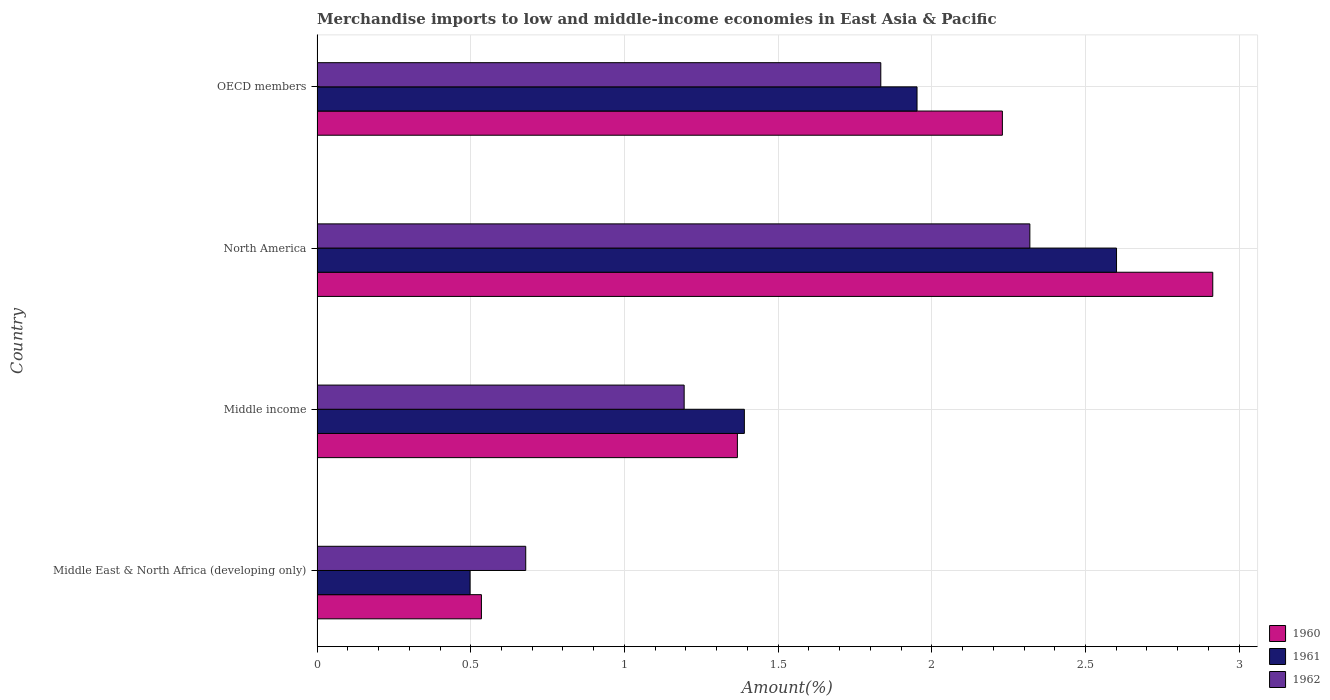How many different coloured bars are there?
Provide a short and direct response. 3. Are the number of bars on each tick of the Y-axis equal?
Offer a terse response. Yes. How many bars are there on the 3rd tick from the top?
Your answer should be very brief. 3. What is the percentage of amount earned from merchandise imports in 1961 in Middle income?
Offer a very short reply. 1.39. Across all countries, what is the maximum percentage of amount earned from merchandise imports in 1962?
Your answer should be compact. 2.32. Across all countries, what is the minimum percentage of amount earned from merchandise imports in 1960?
Your answer should be compact. 0.53. In which country was the percentage of amount earned from merchandise imports in 1961 maximum?
Ensure brevity in your answer.  North America. In which country was the percentage of amount earned from merchandise imports in 1960 minimum?
Your response must be concise. Middle East & North Africa (developing only). What is the total percentage of amount earned from merchandise imports in 1960 in the graph?
Provide a short and direct response. 7.05. What is the difference between the percentage of amount earned from merchandise imports in 1962 in Middle East & North Africa (developing only) and that in Middle income?
Offer a terse response. -0.52. What is the difference between the percentage of amount earned from merchandise imports in 1962 in Middle East & North Africa (developing only) and the percentage of amount earned from merchandise imports in 1961 in OECD members?
Offer a terse response. -1.27. What is the average percentage of amount earned from merchandise imports in 1961 per country?
Offer a terse response. 1.61. What is the difference between the percentage of amount earned from merchandise imports in 1960 and percentage of amount earned from merchandise imports in 1962 in Middle East & North Africa (developing only)?
Make the answer very short. -0.14. In how many countries, is the percentage of amount earned from merchandise imports in 1960 greater than 0.4 %?
Ensure brevity in your answer.  4. What is the ratio of the percentage of amount earned from merchandise imports in 1961 in North America to that in OECD members?
Your answer should be compact. 1.33. What is the difference between the highest and the second highest percentage of amount earned from merchandise imports in 1960?
Your answer should be compact. 0.68. What is the difference between the highest and the lowest percentage of amount earned from merchandise imports in 1961?
Keep it short and to the point. 2.1. In how many countries, is the percentage of amount earned from merchandise imports in 1960 greater than the average percentage of amount earned from merchandise imports in 1960 taken over all countries?
Your answer should be compact. 2. Is the sum of the percentage of amount earned from merchandise imports in 1960 in Middle East & North Africa (developing only) and OECD members greater than the maximum percentage of amount earned from merchandise imports in 1962 across all countries?
Provide a short and direct response. Yes. How many bars are there?
Provide a succinct answer. 12. How many countries are there in the graph?
Provide a succinct answer. 4. Are the values on the major ticks of X-axis written in scientific E-notation?
Your answer should be compact. No. Does the graph contain any zero values?
Your answer should be very brief. No. Where does the legend appear in the graph?
Ensure brevity in your answer.  Bottom right. How many legend labels are there?
Provide a succinct answer. 3. What is the title of the graph?
Your answer should be compact. Merchandise imports to low and middle-income economies in East Asia & Pacific. What is the label or title of the X-axis?
Provide a short and direct response. Amount(%). What is the Amount(%) of 1960 in Middle East & North Africa (developing only)?
Your response must be concise. 0.53. What is the Amount(%) in 1961 in Middle East & North Africa (developing only)?
Give a very brief answer. 0.5. What is the Amount(%) in 1962 in Middle East & North Africa (developing only)?
Provide a short and direct response. 0.68. What is the Amount(%) of 1960 in Middle income?
Ensure brevity in your answer.  1.37. What is the Amount(%) in 1961 in Middle income?
Give a very brief answer. 1.39. What is the Amount(%) of 1962 in Middle income?
Ensure brevity in your answer.  1.19. What is the Amount(%) of 1960 in North America?
Offer a terse response. 2.91. What is the Amount(%) of 1961 in North America?
Your response must be concise. 2.6. What is the Amount(%) in 1962 in North America?
Give a very brief answer. 2.32. What is the Amount(%) of 1960 in OECD members?
Offer a very short reply. 2.23. What is the Amount(%) in 1961 in OECD members?
Ensure brevity in your answer.  1.95. What is the Amount(%) of 1962 in OECD members?
Make the answer very short. 1.83. Across all countries, what is the maximum Amount(%) in 1960?
Provide a succinct answer. 2.91. Across all countries, what is the maximum Amount(%) in 1961?
Offer a terse response. 2.6. Across all countries, what is the maximum Amount(%) of 1962?
Make the answer very short. 2.32. Across all countries, what is the minimum Amount(%) in 1960?
Provide a succinct answer. 0.53. Across all countries, what is the minimum Amount(%) of 1961?
Provide a succinct answer. 0.5. Across all countries, what is the minimum Amount(%) of 1962?
Your answer should be very brief. 0.68. What is the total Amount(%) in 1960 in the graph?
Your answer should be very brief. 7.05. What is the total Amount(%) in 1961 in the graph?
Offer a terse response. 6.44. What is the total Amount(%) of 1962 in the graph?
Provide a short and direct response. 6.03. What is the difference between the Amount(%) in 1960 in Middle East & North Africa (developing only) and that in Middle income?
Offer a terse response. -0.83. What is the difference between the Amount(%) of 1961 in Middle East & North Africa (developing only) and that in Middle income?
Give a very brief answer. -0.89. What is the difference between the Amount(%) of 1962 in Middle East & North Africa (developing only) and that in Middle income?
Your answer should be compact. -0.52. What is the difference between the Amount(%) of 1960 in Middle East & North Africa (developing only) and that in North America?
Provide a succinct answer. -2.38. What is the difference between the Amount(%) in 1961 in Middle East & North Africa (developing only) and that in North America?
Provide a short and direct response. -2.1. What is the difference between the Amount(%) of 1962 in Middle East & North Africa (developing only) and that in North America?
Make the answer very short. -1.64. What is the difference between the Amount(%) of 1960 in Middle East & North Africa (developing only) and that in OECD members?
Provide a succinct answer. -1.69. What is the difference between the Amount(%) of 1961 in Middle East & North Africa (developing only) and that in OECD members?
Provide a short and direct response. -1.45. What is the difference between the Amount(%) in 1962 in Middle East & North Africa (developing only) and that in OECD members?
Provide a succinct answer. -1.16. What is the difference between the Amount(%) in 1960 in Middle income and that in North America?
Offer a terse response. -1.55. What is the difference between the Amount(%) in 1961 in Middle income and that in North America?
Keep it short and to the point. -1.21. What is the difference between the Amount(%) in 1962 in Middle income and that in North America?
Provide a succinct answer. -1.12. What is the difference between the Amount(%) in 1960 in Middle income and that in OECD members?
Your answer should be very brief. -0.86. What is the difference between the Amount(%) of 1961 in Middle income and that in OECD members?
Your response must be concise. -0.56. What is the difference between the Amount(%) of 1962 in Middle income and that in OECD members?
Keep it short and to the point. -0.64. What is the difference between the Amount(%) of 1960 in North America and that in OECD members?
Offer a very short reply. 0.68. What is the difference between the Amount(%) of 1961 in North America and that in OECD members?
Your response must be concise. 0.65. What is the difference between the Amount(%) in 1962 in North America and that in OECD members?
Provide a short and direct response. 0.48. What is the difference between the Amount(%) of 1960 in Middle East & North Africa (developing only) and the Amount(%) of 1961 in Middle income?
Offer a terse response. -0.86. What is the difference between the Amount(%) in 1960 in Middle East & North Africa (developing only) and the Amount(%) in 1962 in Middle income?
Give a very brief answer. -0.66. What is the difference between the Amount(%) of 1961 in Middle East & North Africa (developing only) and the Amount(%) of 1962 in Middle income?
Keep it short and to the point. -0.7. What is the difference between the Amount(%) in 1960 in Middle East & North Africa (developing only) and the Amount(%) in 1961 in North America?
Offer a terse response. -2.07. What is the difference between the Amount(%) of 1960 in Middle East & North Africa (developing only) and the Amount(%) of 1962 in North America?
Provide a short and direct response. -1.78. What is the difference between the Amount(%) in 1961 in Middle East & North Africa (developing only) and the Amount(%) in 1962 in North America?
Offer a terse response. -1.82. What is the difference between the Amount(%) in 1960 in Middle East & North Africa (developing only) and the Amount(%) in 1961 in OECD members?
Provide a succinct answer. -1.42. What is the difference between the Amount(%) of 1960 in Middle East & North Africa (developing only) and the Amount(%) of 1962 in OECD members?
Offer a very short reply. -1.3. What is the difference between the Amount(%) of 1961 in Middle East & North Africa (developing only) and the Amount(%) of 1962 in OECD members?
Make the answer very short. -1.34. What is the difference between the Amount(%) in 1960 in Middle income and the Amount(%) in 1961 in North America?
Keep it short and to the point. -1.23. What is the difference between the Amount(%) of 1960 in Middle income and the Amount(%) of 1962 in North America?
Ensure brevity in your answer.  -0.95. What is the difference between the Amount(%) of 1961 in Middle income and the Amount(%) of 1962 in North America?
Ensure brevity in your answer.  -0.93. What is the difference between the Amount(%) of 1960 in Middle income and the Amount(%) of 1961 in OECD members?
Your answer should be very brief. -0.58. What is the difference between the Amount(%) in 1960 in Middle income and the Amount(%) in 1962 in OECD members?
Your answer should be compact. -0.47. What is the difference between the Amount(%) of 1961 in Middle income and the Amount(%) of 1962 in OECD members?
Give a very brief answer. -0.44. What is the difference between the Amount(%) in 1960 in North America and the Amount(%) in 1961 in OECD members?
Ensure brevity in your answer.  0.96. What is the difference between the Amount(%) in 1961 in North America and the Amount(%) in 1962 in OECD members?
Ensure brevity in your answer.  0.77. What is the average Amount(%) of 1960 per country?
Offer a very short reply. 1.76. What is the average Amount(%) of 1961 per country?
Keep it short and to the point. 1.61. What is the average Amount(%) in 1962 per country?
Your response must be concise. 1.51. What is the difference between the Amount(%) in 1960 and Amount(%) in 1961 in Middle East & North Africa (developing only)?
Your answer should be very brief. 0.04. What is the difference between the Amount(%) in 1960 and Amount(%) in 1962 in Middle East & North Africa (developing only)?
Offer a terse response. -0.14. What is the difference between the Amount(%) of 1961 and Amount(%) of 1962 in Middle East & North Africa (developing only)?
Give a very brief answer. -0.18. What is the difference between the Amount(%) of 1960 and Amount(%) of 1961 in Middle income?
Your answer should be very brief. -0.02. What is the difference between the Amount(%) in 1960 and Amount(%) in 1962 in Middle income?
Your answer should be very brief. 0.17. What is the difference between the Amount(%) of 1961 and Amount(%) of 1962 in Middle income?
Provide a succinct answer. 0.2. What is the difference between the Amount(%) of 1960 and Amount(%) of 1961 in North America?
Provide a short and direct response. 0.31. What is the difference between the Amount(%) in 1960 and Amount(%) in 1962 in North America?
Offer a terse response. 0.6. What is the difference between the Amount(%) in 1961 and Amount(%) in 1962 in North America?
Keep it short and to the point. 0.28. What is the difference between the Amount(%) of 1960 and Amount(%) of 1961 in OECD members?
Make the answer very short. 0.28. What is the difference between the Amount(%) in 1960 and Amount(%) in 1962 in OECD members?
Your answer should be very brief. 0.4. What is the difference between the Amount(%) in 1961 and Amount(%) in 1962 in OECD members?
Your answer should be very brief. 0.12. What is the ratio of the Amount(%) of 1960 in Middle East & North Africa (developing only) to that in Middle income?
Make the answer very short. 0.39. What is the ratio of the Amount(%) in 1961 in Middle East & North Africa (developing only) to that in Middle income?
Your response must be concise. 0.36. What is the ratio of the Amount(%) of 1962 in Middle East & North Africa (developing only) to that in Middle income?
Make the answer very short. 0.57. What is the ratio of the Amount(%) in 1960 in Middle East & North Africa (developing only) to that in North America?
Offer a terse response. 0.18. What is the ratio of the Amount(%) of 1961 in Middle East & North Africa (developing only) to that in North America?
Keep it short and to the point. 0.19. What is the ratio of the Amount(%) in 1962 in Middle East & North Africa (developing only) to that in North America?
Provide a succinct answer. 0.29. What is the ratio of the Amount(%) of 1960 in Middle East & North Africa (developing only) to that in OECD members?
Provide a succinct answer. 0.24. What is the ratio of the Amount(%) of 1961 in Middle East & North Africa (developing only) to that in OECD members?
Offer a very short reply. 0.26. What is the ratio of the Amount(%) of 1962 in Middle East & North Africa (developing only) to that in OECD members?
Ensure brevity in your answer.  0.37. What is the ratio of the Amount(%) in 1960 in Middle income to that in North America?
Your answer should be compact. 0.47. What is the ratio of the Amount(%) in 1961 in Middle income to that in North America?
Provide a succinct answer. 0.53. What is the ratio of the Amount(%) of 1962 in Middle income to that in North America?
Your answer should be compact. 0.52. What is the ratio of the Amount(%) of 1960 in Middle income to that in OECD members?
Give a very brief answer. 0.61. What is the ratio of the Amount(%) of 1961 in Middle income to that in OECD members?
Keep it short and to the point. 0.71. What is the ratio of the Amount(%) of 1962 in Middle income to that in OECD members?
Provide a succinct answer. 0.65. What is the ratio of the Amount(%) in 1960 in North America to that in OECD members?
Provide a short and direct response. 1.31. What is the ratio of the Amount(%) of 1961 in North America to that in OECD members?
Keep it short and to the point. 1.33. What is the ratio of the Amount(%) in 1962 in North America to that in OECD members?
Make the answer very short. 1.26. What is the difference between the highest and the second highest Amount(%) in 1960?
Your answer should be very brief. 0.68. What is the difference between the highest and the second highest Amount(%) in 1961?
Provide a short and direct response. 0.65. What is the difference between the highest and the second highest Amount(%) in 1962?
Keep it short and to the point. 0.48. What is the difference between the highest and the lowest Amount(%) of 1960?
Your answer should be very brief. 2.38. What is the difference between the highest and the lowest Amount(%) of 1961?
Make the answer very short. 2.1. What is the difference between the highest and the lowest Amount(%) of 1962?
Give a very brief answer. 1.64. 